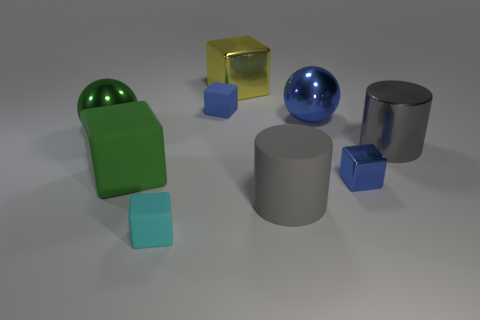Subtract all cyan blocks. How many blocks are left? 4 Subtract 2 blocks. How many blocks are left? 3 Subtract all yellow blocks. How many blocks are left? 4 Subtract all red cubes. Subtract all green spheres. How many cubes are left? 5 Add 1 large green matte cubes. How many objects exist? 10 Subtract all cylinders. How many objects are left? 7 Add 8 large yellow metal cubes. How many large yellow metal cubes are left? 9 Add 6 large brown matte objects. How many large brown matte objects exist? 6 Subtract 1 green cubes. How many objects are left? 8 Subtract all large cyan cubes. Subtract all metallic spheres. How many objects are left? 7 